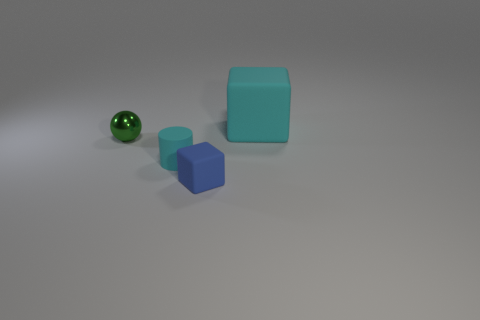Add 3 red cylinders. How many objects exist? 7 Subtract all green blocks. Subtract all yellow cylinders. How many blocks are left? 2 Subtract all cylinders. How many objects are left? 3 Add 4 large cyan blocks. How many large cyan blocks are left? 5 Add 3 small gray metallic balls. How many small gray metallic balls exist? 3 Subtract 0 green cylinders. How many objects are left? 4 Subtract all big blue shiny cylinders. Subtract all blue rubber objects. How many objects are left? 3 